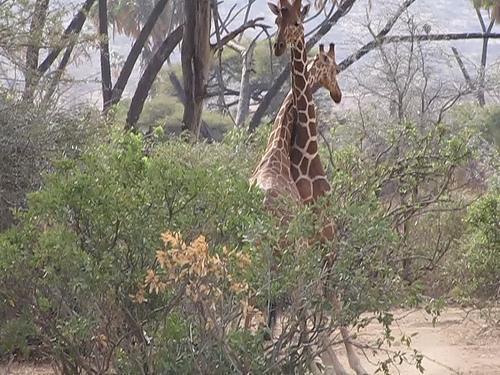How many giraffe are walking in the forest?
Give a very brief answer. 2. How many birds are pictured?
Give a very brief answer. 0. How many animals are there?
Give a very brief answer. 2. How many giraffes are visible?
Give a very brief answer. 2. How many legs does this elephant have?
Give a very brief answer. 0. 